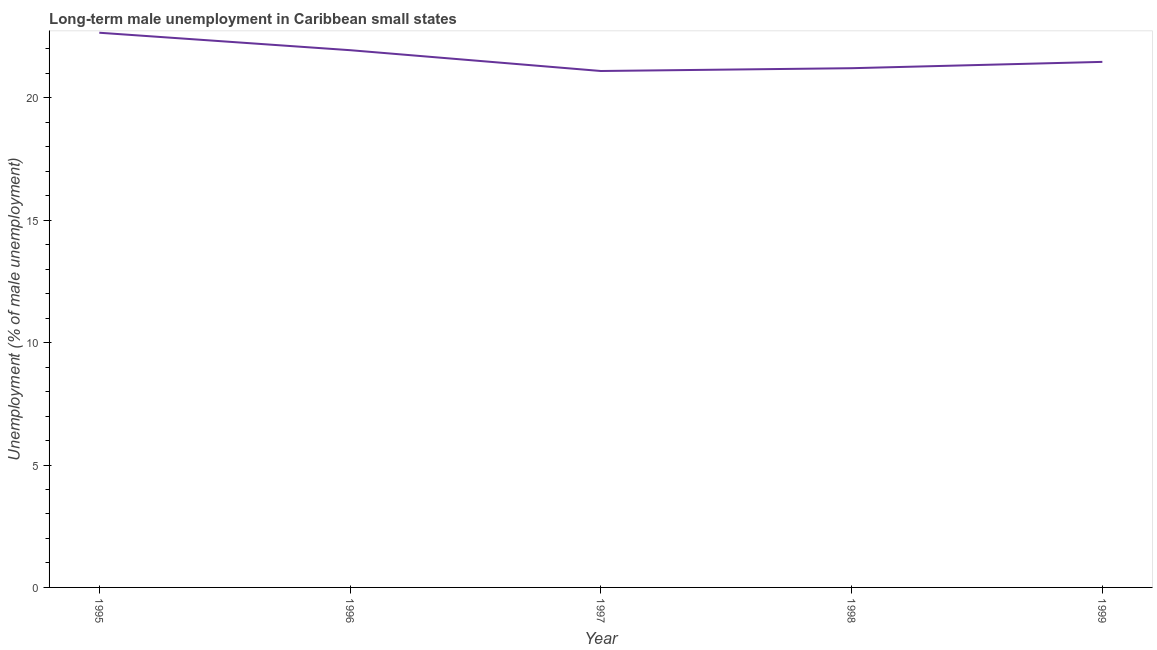What is the long-term male unemployment in 1995?
Offer a very short reply. 22.66. Across all years, what is the maximum long-term male unemployment?
Your response must be concise. 22.66. Across all years, what is the minimum long-term male unemployment?
Your response must be concise. 21.1. In which year was the long-term male unemployment minimum?
Offer a very short reply. 1997. What is the sum of the long-term male unemployment?
Give a very brief answer. 108.39. What is the difference between the long-term male unemployment in 1996 and 1998?
Your response must be concise. 0.74. What is the average long-term male unemployment per year?
Ensure brevity in your answer.  21.68. What is the median long-term male unemployment?
Your answer should be very brief. 21.47. Do a majority of the years between 1996 and 1997 (inclusive) have long-term male unemployment greater than 20 %?
Provide a short and direct response. Yes. What is the ratio of the long-term male unemployment in 1996 to that in 1999?
Your response must be concise. 1.02. Is the long-term male unemployment in 1998 less than that in 1999?
Your response must be concise. Yes. Is the difference between the long-term male unemployment in 1996 and 1999 greater than the difference between any two years?
Provide a succinct answer. No. What is the difference between the highest and the second highest long-term male unemployment?
Your answer should be very brief. 0.71. What is the difference between the highest and the lowest long-term male unemployment?
Keep it short and to the point. 1.56. In how many years, is the long-term male unemployment greater than the average long-term male unemployment taken over all years?
Provide a short and direct response. 2. Are the values on the major ticks of Y-axis written in scientific E-notation?
Provide a succinct answer. No. Does the graph contain any zero values?
Give a very brief answer. No. Does the graph contain grids?
Offer a very short reply. No. What is the title of the graph?
Ensure brevity in your answer.  Long-term male unemployment in Caribbean small states. What is the label or title of the Y-axis?
Provide a short and direct response. Unemployment (% of male unemployment). What is the Unemployment (% of male unemployment) of 1995?
Your answer should be very brief. 22.66. What is the Unemployment (% of male unemployment) in 1996?
Make the answer very short. 21.95. What is the Unemployment (% of male unemployment) in 1997?
Your answer should be very brief. 21.1. What is the Unemployment (% of male unemployment) in 1998?
Keep it short and to the point. 21.21. What is the Unemployment (% of male unemployment) in 1999?
Provide a short and direct response. 21.47. What is the difference between the Unemployment (% of male unemployment) in 1995 and 1996?
Keep it short and to the point. 0.71. What is the difference between the Unemployment (% of male unemployment) in 1995 and 1997?
Your answer should be compact. 1.56. What is the difference between the Unemployment (% of male unemployment) in 1995 and 1998?
Your answer should be very brief. 1.45. What is the difference between the Unemployment (% of male unemployment) in 1995 and 1999?
Offer a terse response. 1.19. What is the difference between the Unemployment (% of male unemployment) in 1996 and 1997?
Provide a short and direct response. 0.85. What is the difference between the Unemployment (% of male unemployment) in 1996 and 1998?
Provide a succinct answer. 0.74. What is the difference between the Unemployment (% of male unemployment) in 1996 and 1999?
Make the answer very short. 0.48. What is the difference between the Unemployment (% of male unemployment) in 1997 and 1998?
Offer a very short reply. -0.11. What is the difference between the Unemployment (% of male unemployment) in 1997 and 1999?
Offer a very short reply. -0.37. What is the difference between the Unemployment (% of male unemployment) in 1998 and 1999?
Your answer should be compact. -0.26. What is the ratio of the Unemployment (% of male unemployment) in 1995 to that in 1996?
Ensure brevity in your answer.  1.03. What is the ratio of the Unemployment (% of male unemployment) in 1995 to that in 1997?
Provide a short and direct response. 1.07. What is the ratio of the Unemployment (% of male unemployment) in 1995 to that in 1998?
Your answer should be very brief. 1.07. What is the ratio of the Unemployment (% of male unemployment) in 1995 to that in 1999?
Make the answer very short. 1.05. What is the ratio of the Unemployment (% of male unemployment) in 1996 to that in 1998?
Your answer should be very brief. 1.03. What is the ratio of the Unemployment (% of male unemployment) in 1997 to that in 1998?
Your answer should be compact. 0.99. What is the ratio of the Unemployment (% of male unemployment) in 1997 to that in 1999?
Give a very brief answer. 0.98. What is the ratio of the Unemployment (% of male unemployment) in 1998 to that in 1999?
Provide a short and direct response. 0.99. 